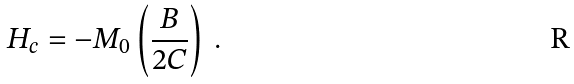Convert formula to latex. <formula><loc_0><loc_0><loc_500><loc_500>H _ { c } = - M _ { 0 } \left ( \frac { B } { 2 C } \right ) \, .</formula> 